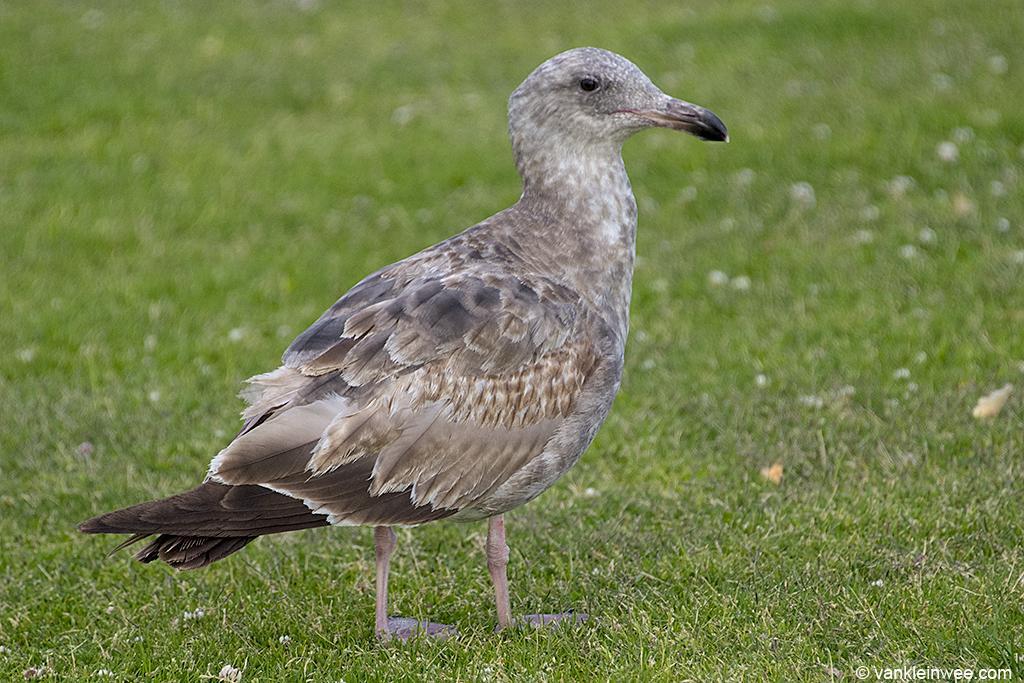In one or two sentences, can you explain what this image depicts? In the foreground I can see a bird is standing on the grass. This image is taken may be during a day on the ground. 